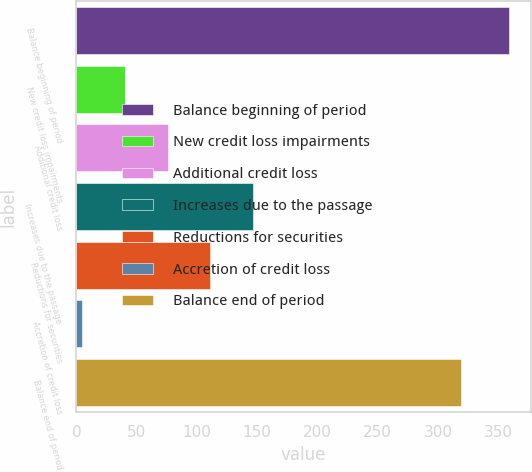<chart> <loc_0><loc_0><loc_500><loc_500><bar_chart><fcel>Balance beginning of period<fcel>New credit loss impairments<fcel>Additional credit loss<fcel>Increases due to the passage<fcel>Reductions for securities<fcel>Accretion of credit loss<fcel>Balance end of period<nl><fcel>359<fcel>40.4<fcel>75.8<fcel>146.6<fcel>111.2<fcel>5<fcel>319<nl></chart> 